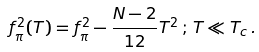<formula> <loc_0><loc_0><loc_500><loc_500>f _ { \pi } ^ { 2 } ( T ) = f _ { \pi } ^ { 2 } - { \frac { N - 2 } { 1 2 } } T ^ { 2 } \, ; \, T \ll T _ { c } \, .</formula> 